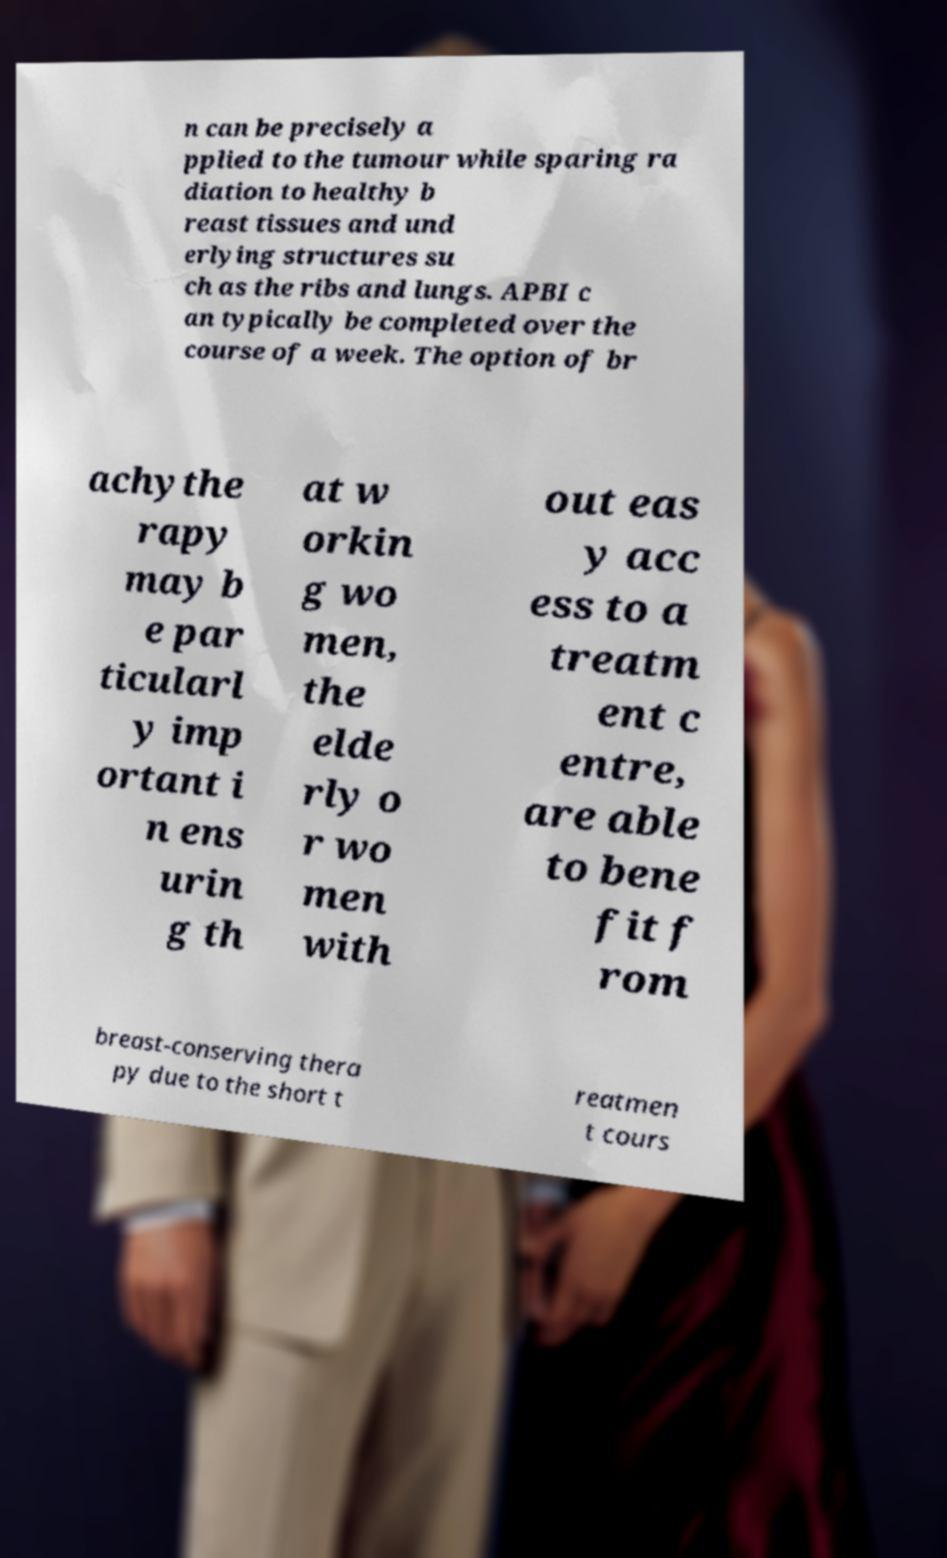Could you extract and type out the text from this image? n can be precisely a pplied to the tumour while sparing ra diation to healthy b reast tissues and und erlying structures su ch as the ribs and lungs. APBI c an typically be completed over the course of a week. The option of br achythe rapy may b e par ticularl y imp ortant i n ens urin g th at w orkin g wo men, the elde rly o r wo men with out eas y acc ess to a treatm ent c entre, are able to bene fit f rom breast-conserving thera py due to the short t reatmen t cours 